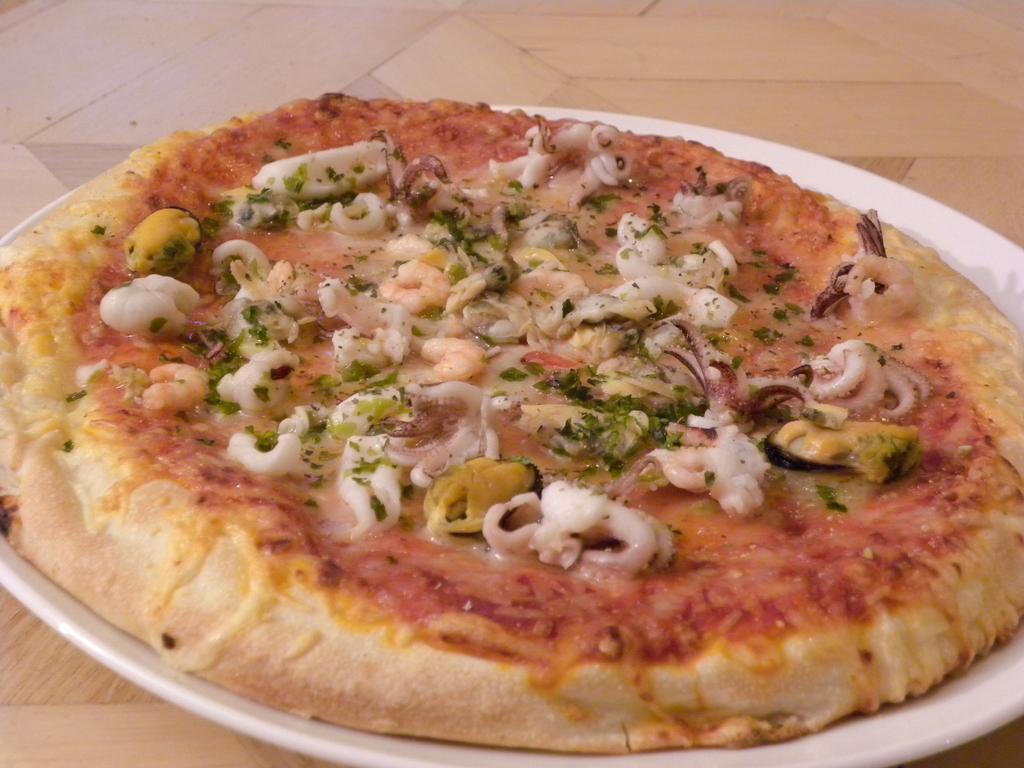In one or two sentences, can you explain what this image depicts? In this image, we can see pizza on the plate, which is placed on the floor. 